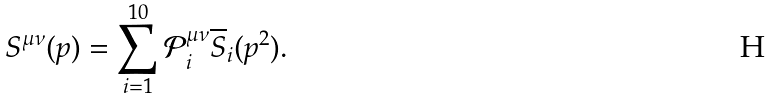Convert formula to latex. <formula><loc_0><loc_0><loc_500><loc_500>S ^ { \mu \nu } ( p ) = \sum _ { i = 1 } ^ { 1 0 } \mathcal { P } ^ { \mu \nu } _ { i } \overline { S } _ { i } ( p ^ { 2 } ) .</formula> 